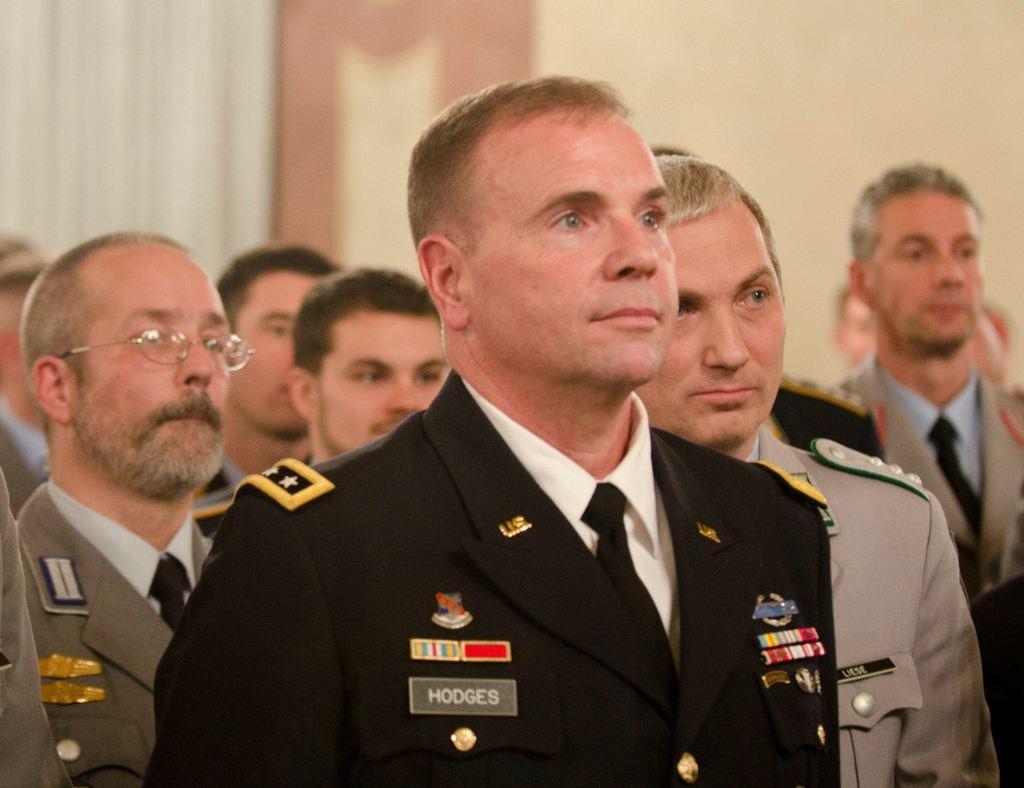Could you give a brief overview of what you see in this image? In this picture we can see group of people, on the left side of the image we can see a man, he wore spectacles and we can see blurry background. 